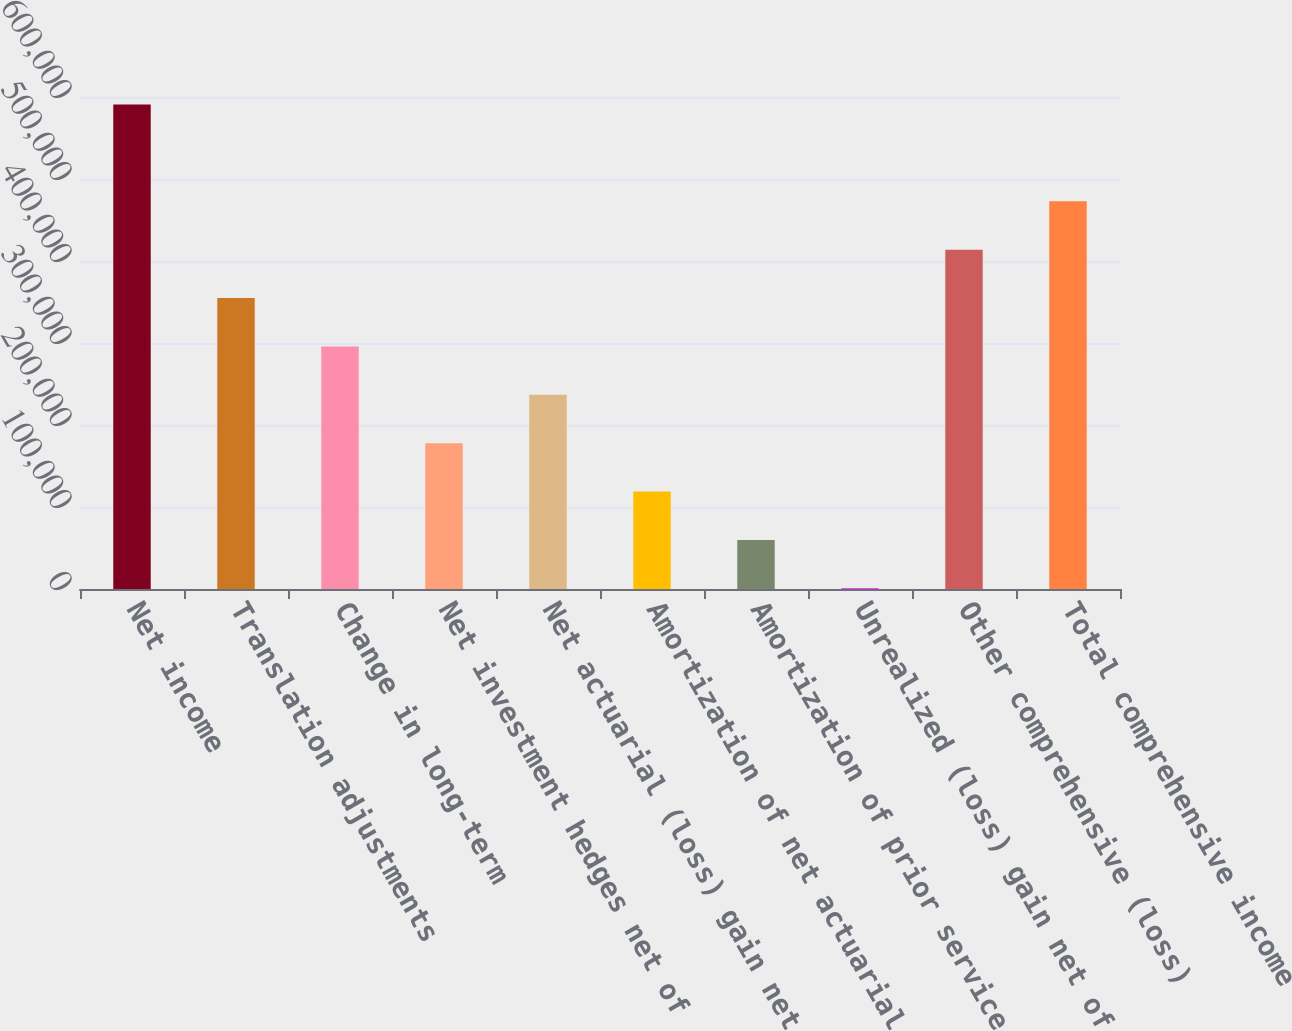Convert chart to OTSL. <chart><loc_0><loc_0><loc_500><loc_500><bar_chart><fcel>Net income<fcel>Translation adjustments<fcel>Change in long-term<fcel>Net investment hedges net of<fcel>Net actuarial (loss) gain net<fcel>Amortization of net actuarial<fcel>Amortization of prior service<fcel>Unrealized (loss) gain net of<fcel>Other comprehensive (loss)<fcel>Total comprehensive income<nl><fcel>590859<fcel>354846<fcel>295843<fcel>177837<fcel>236840<fcel>118833<fcel>59830.2<fcel>827<fcel>413849<fcel>472853<nl></chart> 